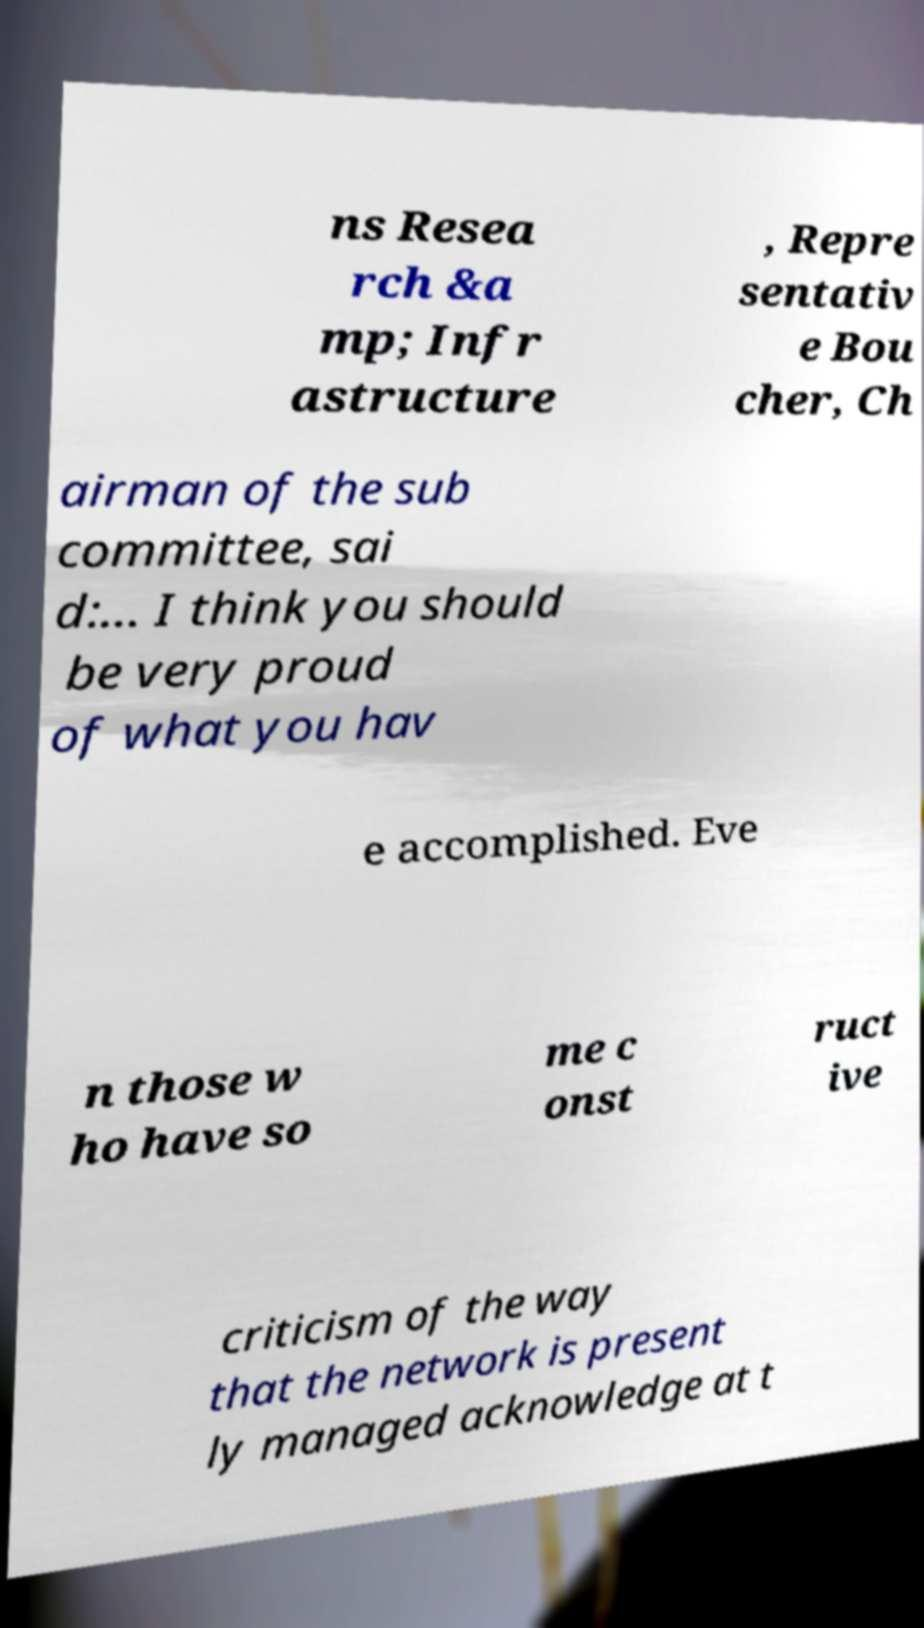Could you assist in decoding the text presented in this image and type it out clearly? ns Resea rch &a mp; Infr astructure , Repre sentativ e Bou cher, Ch airman of the sub committee, sai d:… I think you should be very proud of what you hav e accomplished. Eve n those w ho have so me c onst ruct ive criticism of the way that the network is present ly managed acknowledge at t 